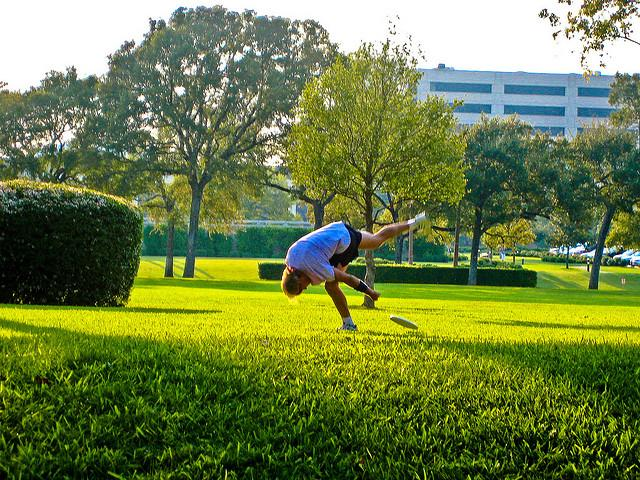What is the possible danger faced by the man? falling 